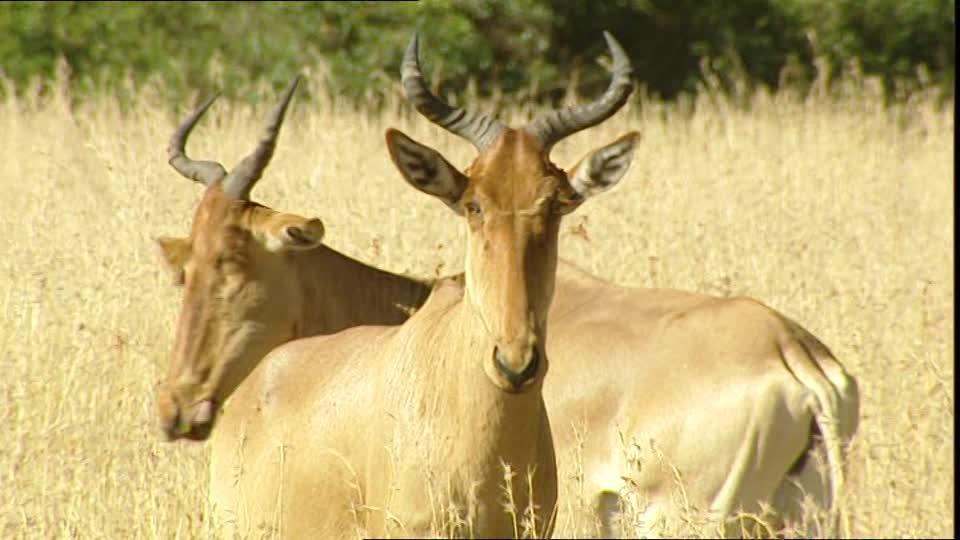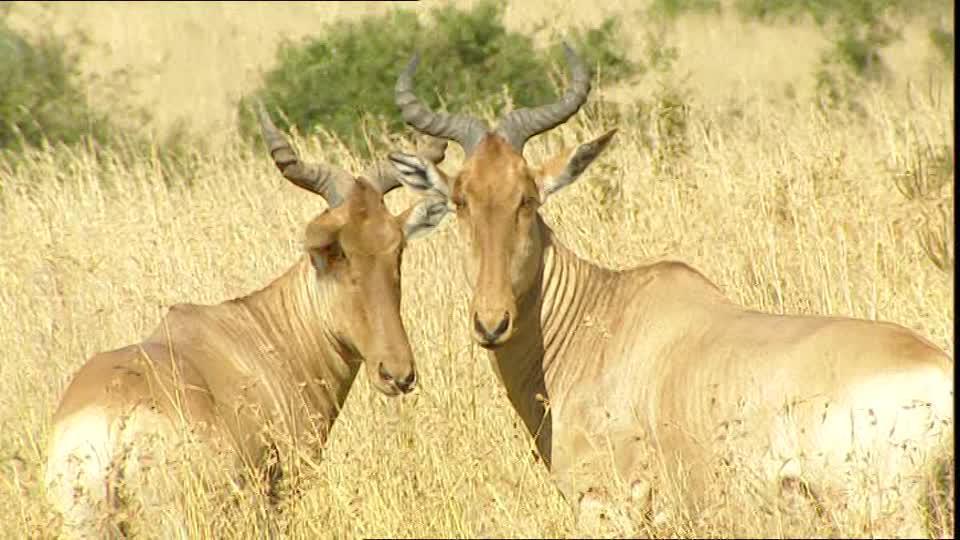The first image is the image on the left, the second image is the image on the right. Evaluate the accuracy of this statement regarding the images: "There are exactly two living animals.". Is it true? Answer yes or no. No. The first image is the image on the left, the second image is the image on the right. Analyze the images presented: Is the assertion "Each image contains multiple horned animals, and one image includes horned animals facing opposite directions and overlapping." valid? Answer yes or no. Yes. 